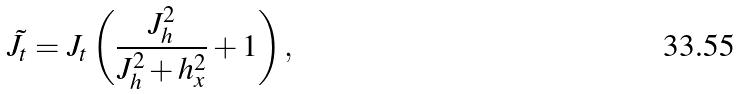Convert formula to latex. <formula><loc_0><loc_0><loc_500><loc_500>\tilde { J } _ { t } = J _ { t } \left ( \frac { J _ { h } ^ { 2 } } { J _ { h } ^ { 2 } + h _ { x } ^ { 2 } } + 1 \right ) ,</formula> 